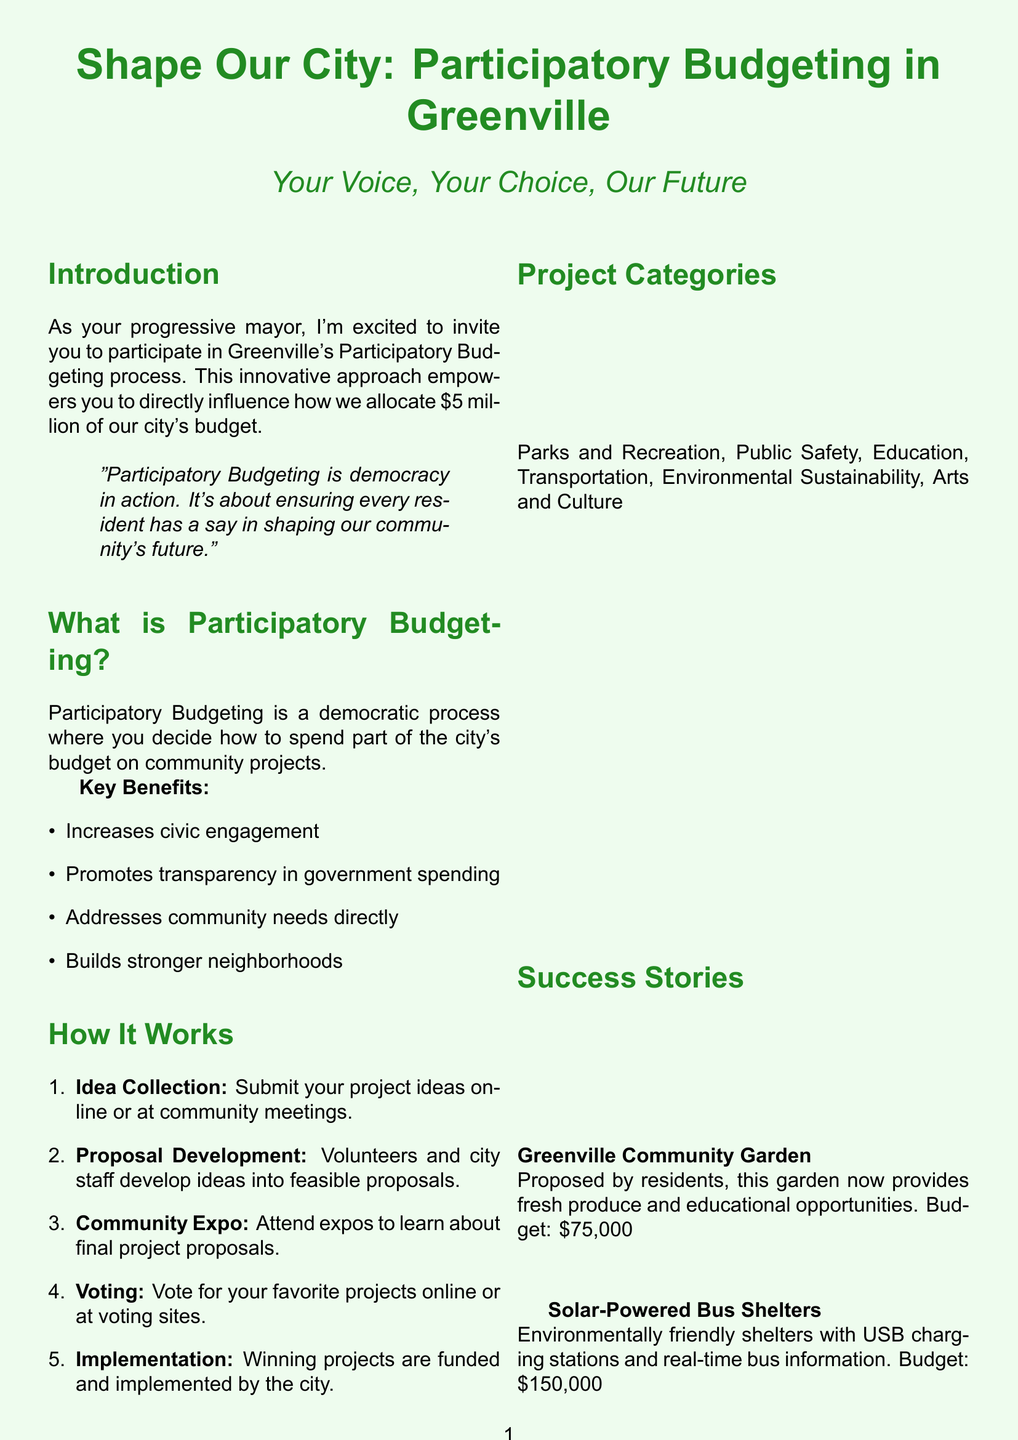What is the title of the brochure? The title is clearly stated at the beginning in the document.
Answer: Shape Our City: Participatory Budgeting in Greenville How much money is allocated for the Participatory Budgeting process? The document specifies the amount of budget available for the process.
Answer: $5 million What is the email address for contact information? The email is explicitly provided in the contact information section of the document.
Answer: participatory.budget@greenville.gov What is one of the project categories listed? The categories of projects are listed as part of the document's content.
Answer: Education Which project had a budget of $150,000? The document provides details about project budgets and names for specific projects.
Answer: Solar-Powered Bus Shelters What is the voting method mentioned for residents? The document outlines the voting process available to community residents.
Answer: Online or at voting sites When does the participatory budgeting process take place? The specified time frame for participation is included in the document content.
Answer: March 1 - April 30, 2023 What type of quotes are included in the introduction? The nature of the quote helps emphasize the message in the document.
Answer: Mayor's quote What benefit of Participatory Budgeting promotes government transparency? The key benefits mentioned allude to promoting transparency in government.
Answer: Promotes transparency in government spending 